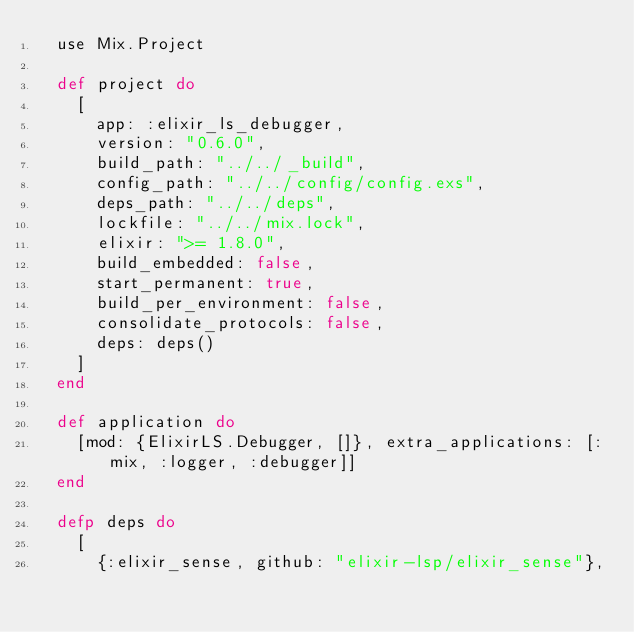Convert code to text. <code><loc_0><loc_0><loc_500><loc_500><_Elixir_>  use Mix.Project

  def project do
    [
      app: :elixir_ls_debugger,
      version: "0.6.0",
      build_path: "../../_build",
      config_path: "../../config/config.exs",
      deps_path: "../../deps",
      lockfile: "../../mix.lock",
      elixir: ">= 1.8.0",
      build_embedded: false,
      start_permanent: true,
      build_per_environment: false,
      consolidate_protocols: false,
      deps: deps()
    ]
  end

  def application do
    [mod: {ElixirLS.Debugger, []}, extra_applications: [:mix, :logger, :debugger]]
  end

  defp deps do
    [
      {:elixir_sense, github: "elixir-lsp/elixir_sense"},</code> 